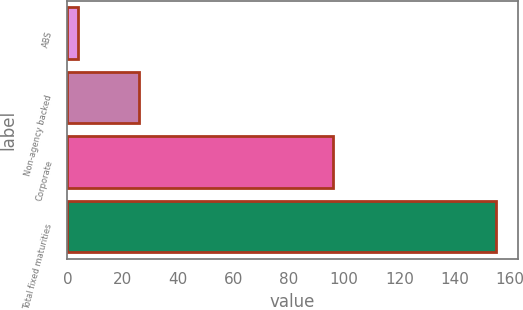Convert chart. <chart><loc_0><loc_0><loc_500><loc_500><bar_chart><fcel>ABS<fcel>Non-agency backed<fcel>Corporate<fcel>Total fixed maturities<nl><fcel>4<fcel>26<fcel>96<fcel>155<nl></chart> 